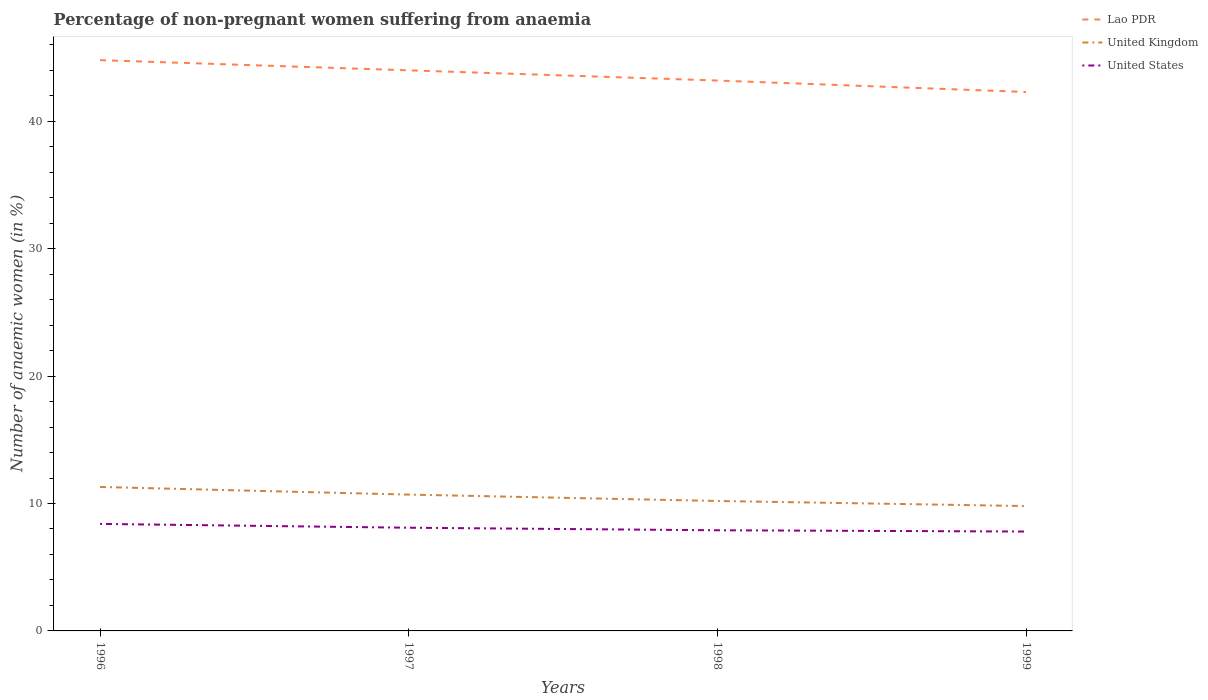How many different coloured lines are there?
Offer a terse response. 3. Does the line corresponding to United Kingdom intersect with the line corresponding to United States?
Offer a very short reply. No. Is the number of lines equal to the number of legend labels?
Provide a succinct answer. Yes. Across all years, what is the maximum percentage of non-pregnant women suffering from anaemia in United Kingdom?
Provide a succinct answer. 9.8. What is the total percentage of non-pregnant women suffering from anaemia in United Kingdom in the graph?
Offer a very short reply. 1.5. Is the percentage of non-pregnant women suffering from anaemia in Lao PDR strictly greater than the percentage of non-pregnant women suffering from anaemia in United Kingdom over the years?
Your answer should be very brief. No. How many lines are there?
Give a very brief answer. 3. How many years are there in the graph?
Offer a terse response. 4. What is the difference between two consecutive major ticks on the Y-axis?
Your response must be concise. 10. Does the graph contain any zero values?
Your answer should be compact. No. Does the graph contain grids?
Your response must be concise. No. Where does the legend appear in the graph?
Keep it short and to the point. Top right. How many legend labels are there?
Provide a succinct answer. 3. What is the title of the graph?
Make the answer very short. Percentage of non-pregnant women suffering from anaemia. What is the label or title of the X-axis?
Provide a short and direct response. Years. What is the label or title of the Y-axis?
Make the answer very short. Number of anaemic women (in %). What is the Number of anaemic women (in %) in Lao PDR in 1996?
Offer a terse response. 44.8. What is the Number of anaemic women (in %) of Lao PDR in 1997?
Your response must be concise. 44. What is the Number of anaemic women (in %) of United Kingdom in 1997?
Ensure brevity in your answer.  10.7. What is the Number of anaemic women (in %) in United States in 1997?
Offer a very short reply. 8.1. What is the Number of anaemic women (in %) in Lao PDR in 1998?
Your answer should be very brief. 43.2. What is the Number of anaemic women (in %) of Lao PDR in 1999?
Your answer should be very brief. 42.3. What is the Number of anaemic women (in %) of United States in 1999?
Your answer should be very brief. 7.8. Across all years, what is the maximum Number of anaemic women (in %) in Lao PDR?
Make the answer very short. 44.8. Across all years, what is the minimum Number of anaemic women (in %) in Lao PDR?
Give a very brief answer. 42.3. Across all years, what is the minimum Number of anaemic women (in %) in United States?
Offer a very short reply. 7.8. What is the total Number of anaemic women (in %) of Lao PDR in the graph?
Give a very brief answer. 174.3. What is the total Number of anaemic women (in %) of United Kingdom in the graph?
Offer a very short reply. 42. What is the total Number of anaemic women (in %) of United States in the graph?
Your response must be concise. 32.2. What is the difference between the Number of anaemic women (in %) of Lao PDR in 1996 and that in 1997?
Provide a succinct answer. 0.8. What is the difference between the Number of anaemic women (in %) of United States in 1996 and that in 1997?
Your response must be concise. 0.3. What is the difference between the Number of anaemic women (in %) of Lao PDR in 1996 and that in 1998?
Ensure brevity in your answer.  1.6. What is the difference between the Number of anaemic women (in %) in United Kingdom in 1996 and that in 1998?
Offer a terse response. 1.1. What is the difference between the Number of anaemic women (in %) in United States in 1996 and that in 1998?
Ensure brevity in your answer.  0.5. What is the difference between the Number of anaemic women (in %) of Lao PDR in 1996 and that in 1999?
Offer a very short reply. 2.5. What is the difference between the Number of anaemic women (in %) of United Kingdom in 1996 and that in 1999?
Give a very brief answer. 1.5. What is the difference between the Number of anaemic women (in %) in United States in 1996 and that in 1999?
Make the answer very short. 0.6. What is the difference between the Number of anaemic women (in %) in Lao PDR in 1997 and that in 1998?
Keep it short and to the point. 0.8. What is the difference between the Number of anaemic women (in %) in United States in 1997 and that in 1998?
Your response must be concise. 0.2. What is the difference between the Number of anaemic women (in %) of United States in 1997 and that in 1999?
Your response must be concise. 0.3. What is the difference between the Number of anaemic women (in %) of Lao PDR in 1998 and that in 1999?
Make the answer very short. 0.9. What is the difference between the Number of anaemic women (in %) in United Kingdom in 1998 and that in 1999?
Your response must be concise. 0.4. What is the difference between the Number of anaemic women (in %) in Lao PDR in 1996 and the Number of anaemic women (in %) in United Kingdom in 1997?
Your answer should be compact. 34.1. What is the difference between the Number of anaemic women (in %) in Lao PDR in 1996 and the Number of anaemic women (in %) in United States in 1997?
Your answer should be compact. 36.7. What is the difference between the Number of anaemic women (in %) of Lao PDR in 1996 and the Number of anaemic women (in %) of United Kingdom in 1998?
Make the answer very short. 34.6. What is the difference between the Number of anaemic women (in %) of Lao PDR in 1996 and the Number of anaemic women (in %) of United States in 1998?
Your response must be concise. 36.9. What is the difference between the Number of anaemic women (in %) of United Kingdom in 1996 and the Number of anaemic women (in %) of United States in 1998?
Keep it short and to the point. 3.4. What is the difference between the Number of anaemic women (in %) in Lao PDR in 1996 and the Number of anaemic women (in %) in United Kingdom in 1999?
Offer a terse response. 35. What is the difference between the Number of anaemic women (in %) of United Kingdom in 1996 and the Number of anaemic women (in %) of United States in 1999?
Ensure brevity in your answer.  3.5. What is the difference between the Number of anaemic women (in %) of Lao PDR in 1997 and the Number of anaemic women (in %) of United Kingdom in 1998?
Offer a terse response. 33.8. What is the difference between the Number of anaemic women (in %) in Lao PDR in 1997 and the Number of anaemic women (in %) in United States in 1998?
Your answer should be compact. 36.1. What is the difference between the Number of anaemic women (in %) in Lao PDR in 1997 and the Number of anaemic women (in %) in United Kingdom in 1999?
Your answer should be compact. 34.2. What is the difference between the Number of anaemic women (in %) of Lao PDR in 1997 and the Number of anaemic women (in %) of United States in 1999?
Offer a terse response. 36.2. What is the difference between the Number of anaemic women (in %) of United Kingdom in 1997 and the Number of anaemic women (in %) of United States in 1999?
Your response must be concise. 2.9. What is the difference between the Number of anaemic women (in %) in Lao PDR in 1998 and the Number of anaemic women (in %) in United Kingdom in 1999?
Provide a short and direct response. 33.4. What is the difference between the Number of anaemic women (in %) in Lao PDR in 1998 and the Number of anaemic women (in %) in United States in 1999?
Offer a terse response. 35.4. What is the difference between the Number of anaemic women (in %) in United Kingdom in 1998 and the Number of anaemic women (in %) in United States in 1999?
Ensure brevity in your answer.  2.4. What is the average Number of anaemic women (in %) in Lao PDR per year?
Ensure brevity in your answer.  43.58. What is the average Number of anaemic women (in %) in United States per year?
Keep it short and to the point. 8.05. In the year 1996, what is the difference between the Number of anaemic women (in %) in Lao PDR and Number of anaemic women (in %) in United Kingdom?
Make the answer very short. 33.5. In the year 1996, what is the difference between the Number of anaemic women (in %) in Lao PDR and Number of anaemic women (in %) in United States?
Make the answer very short. 36.4. In the year 1996, what is the difference between the Number of anaemic women (in %) of United Kingdom and Number of anaemic women (in %) of United States?
Provide a succinct answer. 2.9. In the year 1997, what is the difference between the Number of anaemic women (in %) of Lao PDR and Number of anaemic women (in %) of United Kingdom?
Make the answer very short. 33.3. In the year 1997, what is the difference between the Number of anaemic women (in %) of Lao PDR and Number of anaemic women (in %) of United States?
Your response must be concise. 35.9. In the year 1998, what is the difference between the Number of anaemic women (in %) in Lao PDR and Number of anaemic women (in %) in United States?
Provide a short and direct response. 35.3. In the year 1998, what is the difference between the Number of anaemic women (in %) in United Kingdom and Number of anaemic women (in %) in United States?
Your answer should be very brief. 2.3. In the year 1999, what is the difference between the Number of anaemic women (in %) in Lao PDR and Number of anaemic women (in %) in United Kingdom?
Offer a very short reply. 32.5. In the year 1999, what is the difference between the Number of anaemic women (in %) of Lao PDR and Number of anaemic women (in %) of United States?
Ensure brevity in your answer.  34.5. In the year 1999, what is the difference between the Number of anaemic women (in %) of United Kingdom and Number of anaemic women (in %) of United States?
Ensure brevity in your answer.  2. What is the ratio of the Number of anaemic women (in %) in Lao PDR in 1996 to that in 1997?
Your answer should be very brief. 1.02. What is the ratio of the Number of anaemic women (in %) of United Kingdom in 1996 to that in 1997?
Offer a very short reply. 1.06. What is the ratio of the Number of anaemic women (in %) of United Kingdom in 1996 to that in 1998?
Provide a succinct answer. 1.11. What is the ratio of the Number of anaemic women (in %) of United States in 1996 to that in 1998?
Your response must be concise. 1.06. What is the ratio of the Number of anaemic women (in %) in Lao PDR in 1996 to that in 1999?
Make the answer very short. 1.06. What is the ratio of the Number of anaemic women (in %) of United Kingdom in 1996 to that in 1999?
Your answer should be compact. 1.15. What is the ratio of the Number of anaemic women (in %) of United States in 1996 to that in 1999?
Your answer should be compact. 1.08. What is the ratio of the Number of anaemic women (in %) of Lao PDR in 1997 to that in 1998?
Ensure brevity in your answer.  1.02. What is the ratio of the Number of anaemic women (in %) in United Kingdom in 1997 to that in 1998?
Keep it short and to the point. 1.05. What is the ratio of the Number of anaemic women (in %) in United States in 1997 to that in 1998?
Provide a succinct answer. 1.03. What is the ratio of the Number of anaemic women (in %) in Lao PDR in 1997 to that in 1999?
Your response must be concise. 1.04. What is the ratio of the Number of anaemic women (in %) of United Kingdom in 1997 to that in 1999?
Provide a succinct answer. 1.09. What is the ratio of the Number of anaemic women (in %) of Lao PDR in 1998 to that in 1999?
Ensure brevity in your answer.  1.02. What is the ratio of the Number of anaemic women (in %) of United Kingdom in 1998 to that in 1999?
Make the answer very short. 1.04. What is the ratio of the Number of anaemic women (in %) of United States in 1998 to that in 1999?
Offer a terse response. 1.01. 